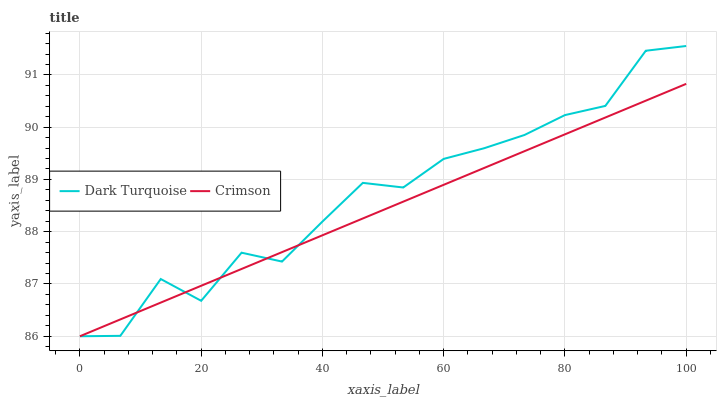Does Crimson have the minimum area under the curve?
Answer yes or no. Yes. Does Dark Turquoise have the maximum area under the curve?
Answer yes or no. Yes. Does Dark Turquoise have the minimum area under the curve?
Answer yes or no. No. Is Crimson the smoothest?
Answer yes or no. Yes. Is Dark Turquoise the roughest?
Answer yes or no. Yes. Is Dark Turquoise the smoothest?
Answer yes or no. No. Does Crimson have the lowest value?
Answer yes or no. Yes. Does Dark Turquoise have the highest value?
Answer yes or no. Yes. Does Dark Turquoise intersect Crimson?
Answer yes or no. Yes. Is Dark Turquoise less than Crimson?
Answer yes or no. No. Is Dark Turquoise greater than Crimson?
Answer yes or no. No. 